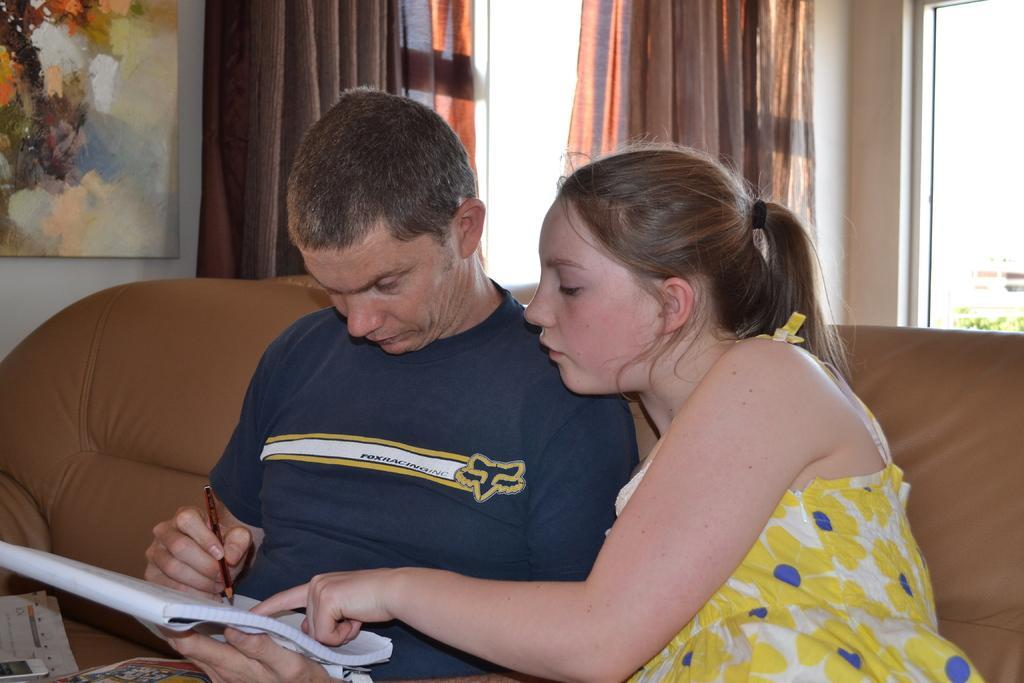In one or two sentences, can you explain what this image depicts? In this picture there is a man sitting and holding the pen and book and there is a girl sitting. There is a paper and device on the sofa. At the back there is a board on the wall, there is painting on the board and there are curtains at the windows. Behind the window there is a plant. 